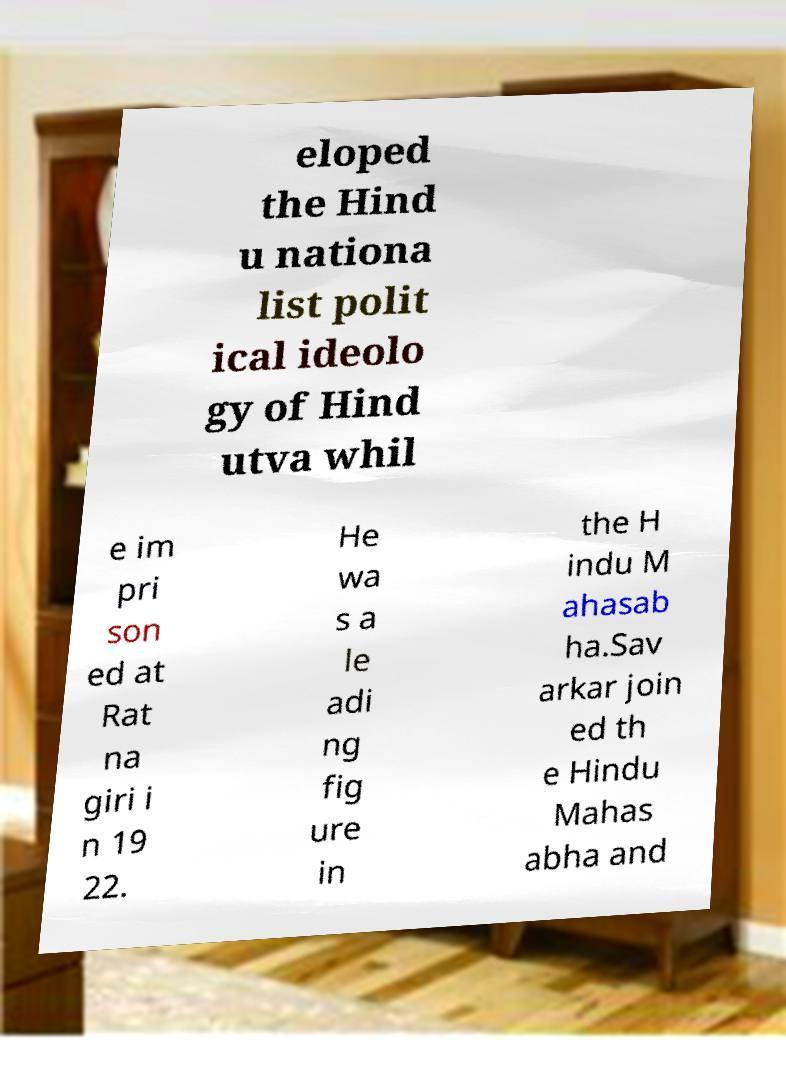What messages or text are displayed in this image? I need them in a readable, typed format. eloped the Hind u nationa list polit ical ideolo gy of Hind utva whil e im pri son ed at Rat na giri i n 19 22. He wa s a le adi ng fig ure in the H indu M ahasab ha.Sav arkar join ed th e Hindu Mahas abha and 